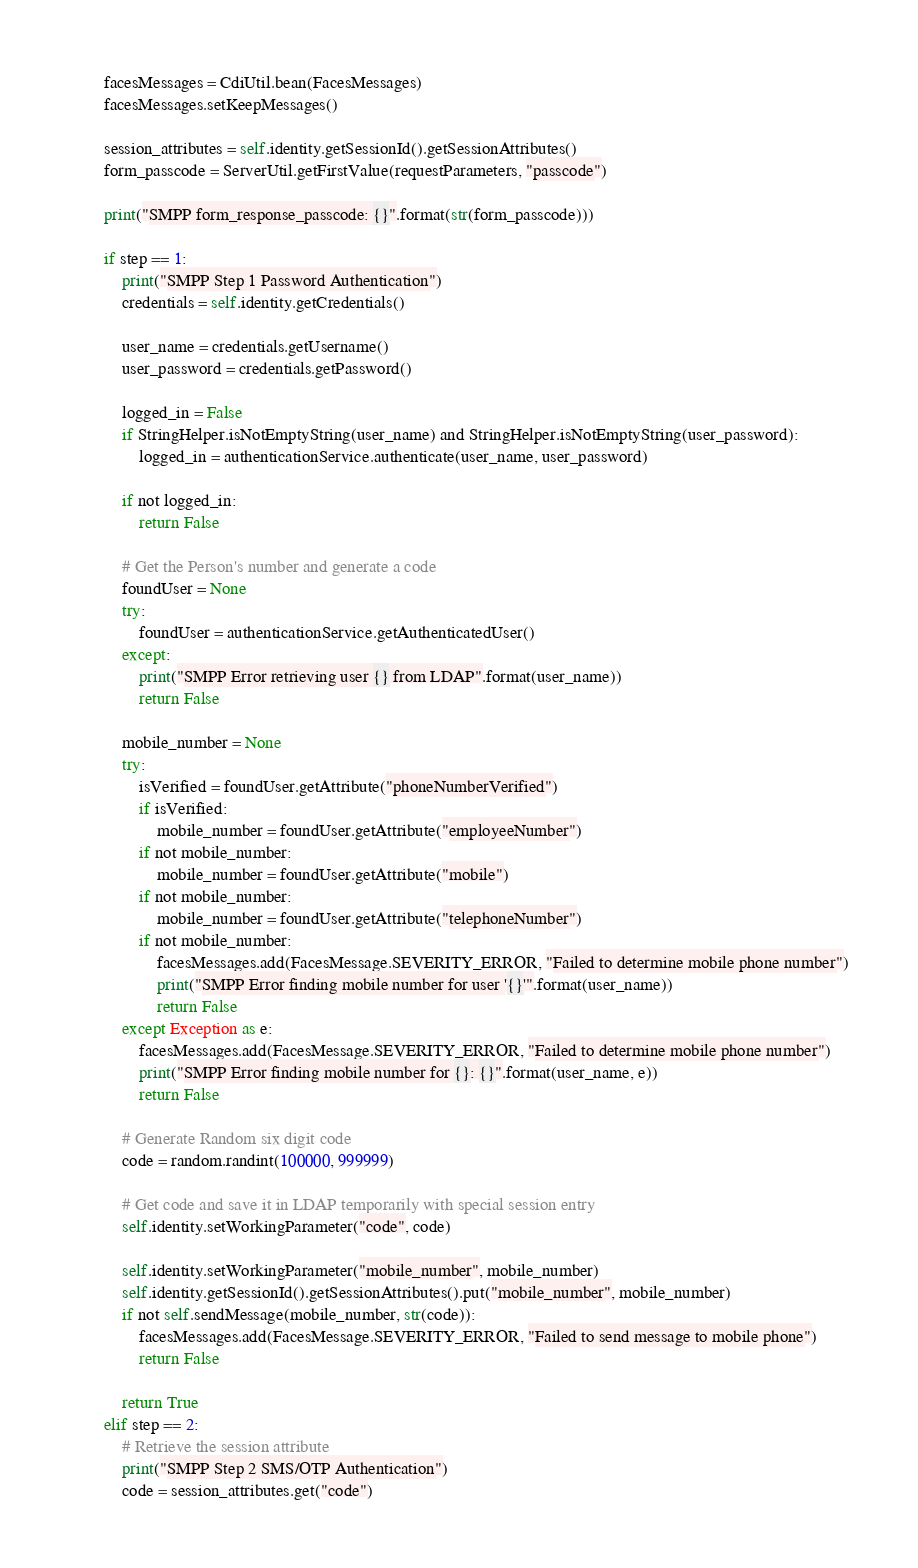Convert code to text. <code><loc_0><loc_0><loc_500><loc_500><_Python_>        facesMessages = CdiUtil.bean(FacesMessages)
        facesMessages.setKeepMessages()

        session_attributes = self.identity.getSessionId().getSessionAttributes()
        form_passcode = ServerUtil.getFirstValue(requestParameters, "passcode")

        print("SMPP form_response_passcode: {}".format(str(form_passcode)))

        if step == 1:
            print("SMPP Step 1 Password Authentication")
            credentials = self.identity.getCredentials()

            user_name = credentials.getUsername()
            user_password = credentials.getPassword()

            logged_in = False
            if StringHelper.isNotEmptyString(user_name) and StringHelper.isNotEmptyString(user_password):
                logged_in = authenticationService.authenticate(user_name, user_password)

            if not logged_in:
                return False

            # Get the Person's number and generate a code
            foundUser = None
            try:
                foundUser = authenticationService.getAuthenticatedUser()
            except:
                print("SMPP Error retrieving user {} from LDAP".format(user_name))
                return False

            mobile_number = None
            try:
                isVerified = foundUser.getAttribute("phoneNumberVerified")
                if isVerified:
                    mobile_number = foundUser.getAttribute("employeeNumber")
                if not mobile_number:
                    mobile_number = foundUser.getAttribute("mobile")
                if not mobile_number:
                    mobile_number = foundUser.getAttribute("telephoneNumber")
                if not mobile_number:
                    facesMessages.add(FacesMessage.SEVERITY_ERROR, "Failed to determine mobile phone number")
                    print("SMPP Error finding mobile number for user '{}'".format(user_name))
                    return False
            except Exception as e:
                facesMessages.add(FacesMessage.SEVERITY_ERROR, "Failed to determine mobile phone number")
                print("SMPP Error finding mobile number for {}: {}".format(user_name, e))
                return False

            # Generate Random six digit code
            code = random.randint(100000, 999999)

            # Get code and save it in LDAP temporarily with special session entry
            self.identity.setWorkingParameter("code", code)

            self.identity.setWorkingParameter("mobile_number", mobile_number)
            self.identity.getSessionId().getSessionAttributes().put("mobile_number", mobile_number)
            if not self.sendMessage(mobile_number, str(code)):
                facesMessages.add(FacesMessage.SEVERITY_ERROR, "Failed to send message to mobile phone")
                return False

            return True
        elif step == 2:
            # Retrieve the session attribute
            print("SMPP Step 2 SMS/OTP Authentication")
            code = session_attributes.get("code")</code> 